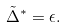Convert formula to latex. <formula><loc_0><loc_0><loc_500><loc_500>\tilde { \Delta } ^ { * } = \epsilon .</formula> 